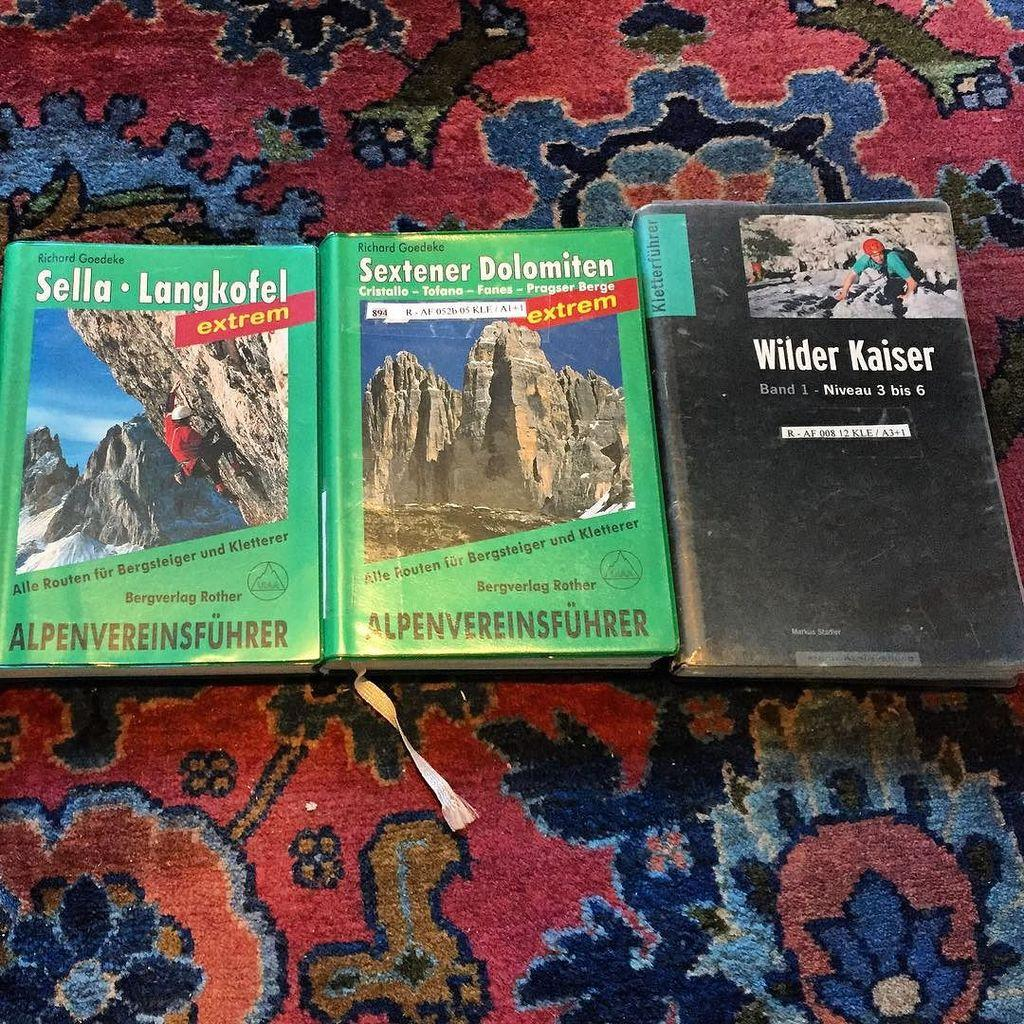<image>
Give a short and clear explanation of the subsequent image. The last 4 characters on the identification label, Wilder Kaiser book, is A3+1. 